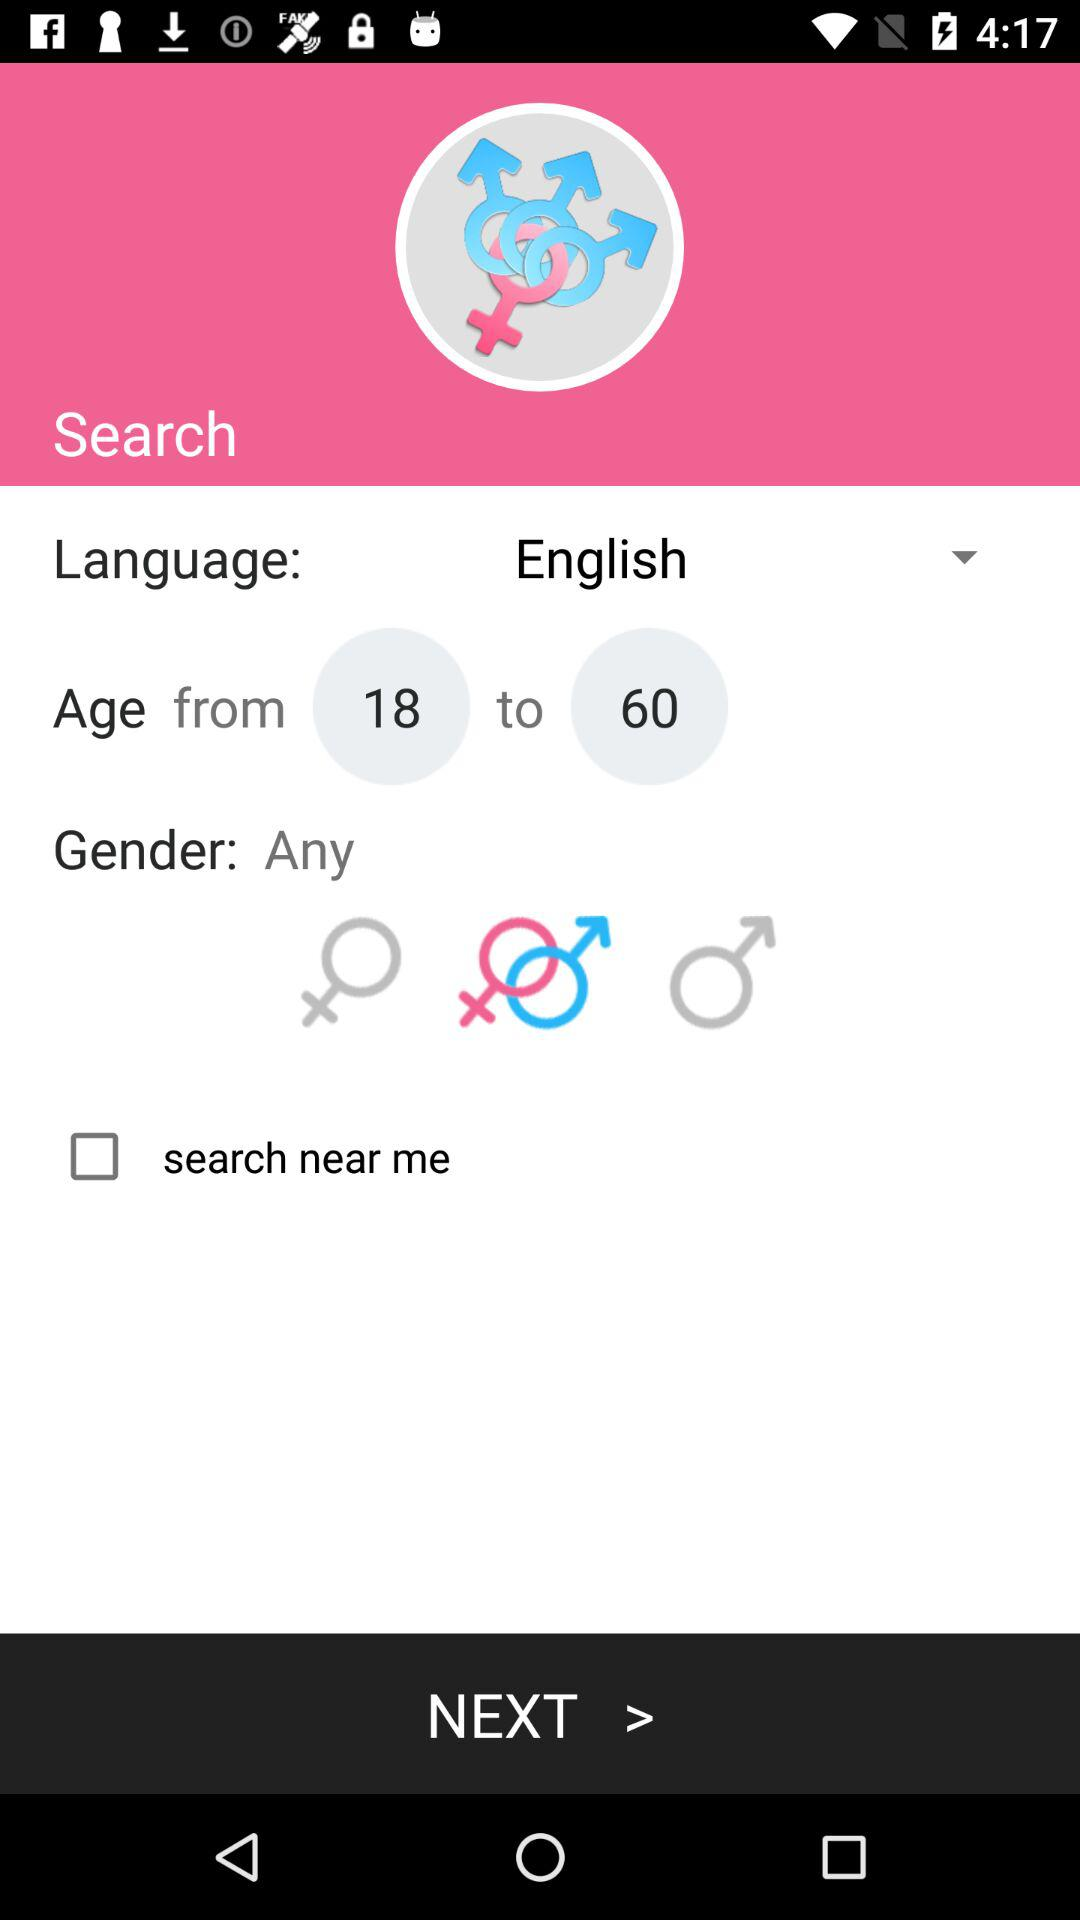What is the age limit? The age limit is 18 to 60. 